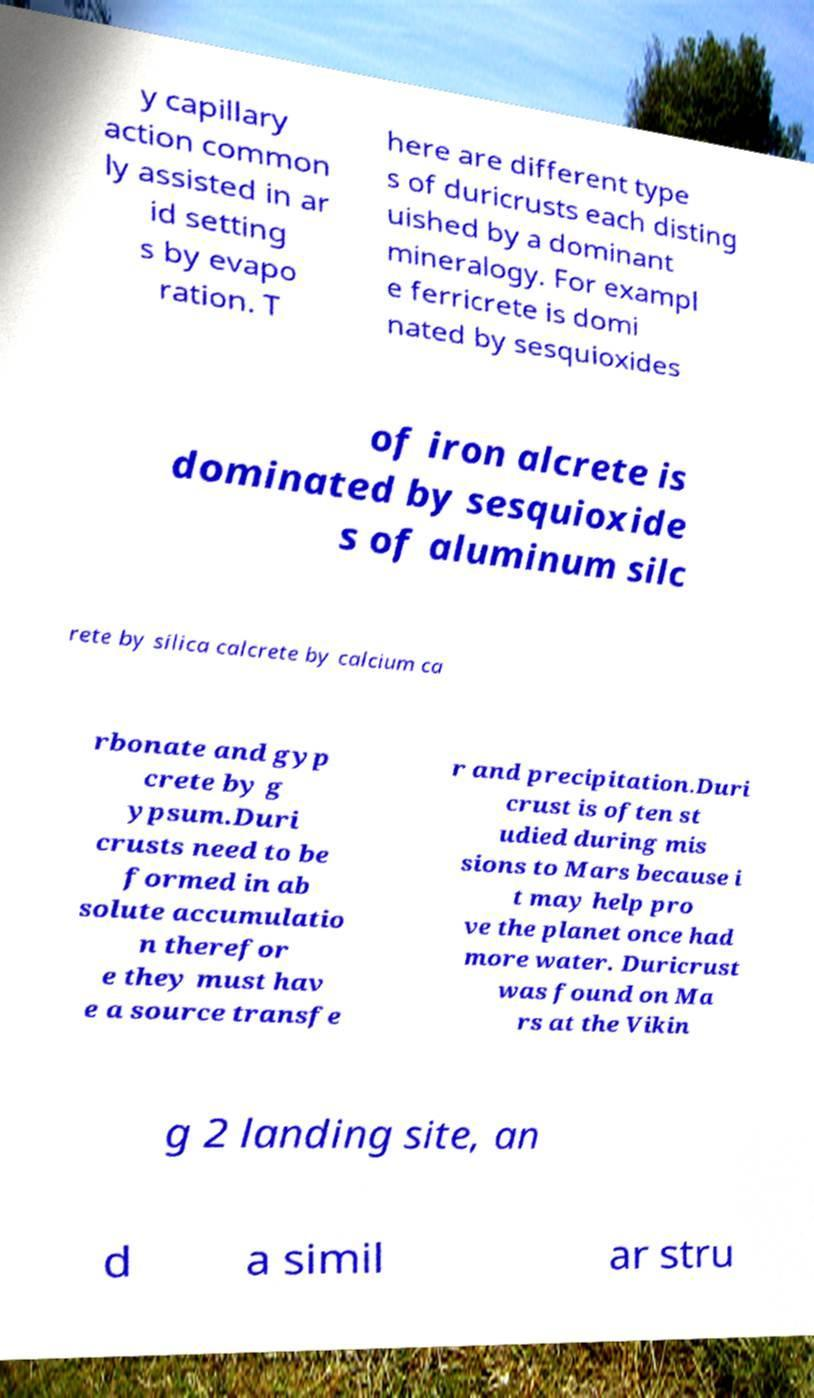For documentation purposes, I need the text within this image transcribed. Could you provide that? y capillary action common ly assisted in ar id setting s by evapo ration. T here are different type s of duricrusts each disting uished by a dominant mineralogy. For exampl e ferricrete is domi nated by sesquioxides of iron alcrete is dominated by sesquioxide s of aluminum silc rete by silica calcrete by calcium ca rbonate and gyp crete by g ypsum.Duri crusts need to be formed in ab solute accumulatio n therefor e they must hav e a source transfe r and precipitation.Duri crust is often st udied during mis sions to Mars because i t may help pro ve the planet once had more water. Duricrust was found on Ma rs at the Vikin g 2 landing site, an d a simil ar stru 